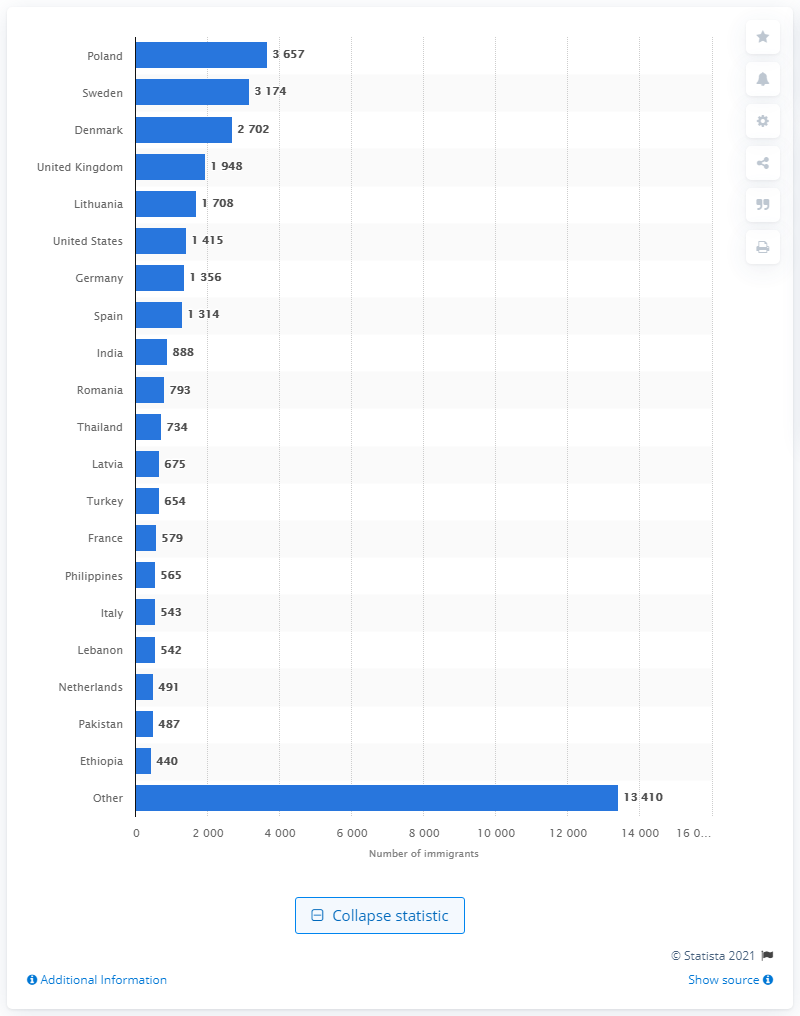Identify some key points in this picture. Sweden was the second most popular country of origin in Norway. 